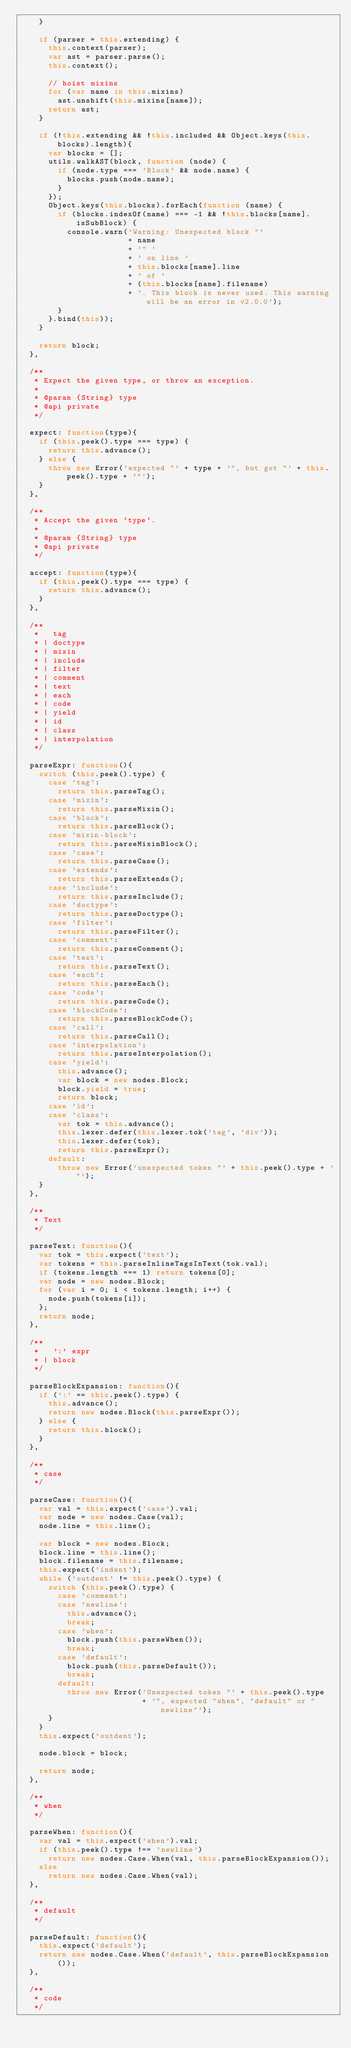Convert code to text. <code><loc_0><loc_0><loc_500><loc_500><_JavaScript_>    }

    if (parser = this.extending) {
      this.context(parser);
      var ast = parser.parse();
      this.context();

      // hoist mixins
      for (var name in this.mixins)
        ast.unshift(this.mixins[name]);
      return ast;
    }

    if (!this.extending && !this.included && Object.keys(this.blocks).length){
      var blocks = [];
      utils.walkAST(block, function (node) {
        if (node.type === 'Block' && node.name) {
          blocks.push(node.name);
        }
      });
      Object.keys(this.blocks).forEach(function (name) {
        if (blocks.indexOf(name) === -1 && !this.blocks[name].isSubBlock) {
          console.warn('Warning: Unexpected block "'
                       + name
                       + '" '
                       + ' on line '
                       + this.blocks[name].line
                       + ' of '
                       + (this.blocks[name].filename)
                       + '. This block is never used. This warning will be an error in v2.0.0');
        }
      }.bind(this));
    }

    return block;
  },

  /**
   * Expect the given type, or throw an exception.
   *
   * @param {String} type
   * @api private
   */

  expect: function(type){
    if (this.peek().type === type) {
      return this.advance();
    } else {
      throw new Error('expected "' + type + '", but got "' + this.peek().type + '"');
    }
  },

  /**
   * Accept the given `type`.
   *
   * @param {String} type
   * @api private
   */

  accept: function(type){
    if (this.peek().type === type) {
      return this.advance();
    }
  },

  /**
   *   tag
   * | doctype
   * | mixin
   * | include
   * | filter
   * | comment
   * | text
   * | each
   * | code
   * | yield
   * | id
   * | class
   * | interpolation
   */

  parseExpr: function(){
    switch (this.peek().type) {
      case 'tag':
        return this.parseTag();
      case 'mixin':
        return this.parseMixin();
      case 'block':
        return this.parseBlock();
      case 'mixin-block':
        return this.parseMixinBlock();
      case 'case':
        return this.parseCase();
      case 'extends':
        return this.parseExtends();
      case 'include':
        return this.parseInclude();
      case 'doctype':
        return this.parseDoctype();
      case 'filter':
        return this.parseFilter();
      case 'comment':
        return this.parseComment();
      case 'text':
        return this.parseText();
      case 'each':
        return this.parseEach();
      case 'code':
        return this.parseCode();
      case 'blockCode':
        return this.parseBlockCode();
      case 'call':
        return this.parseCall();
      case 'interpolation':
        return this.parseInterpolation();
      case 'yield':
        this.advance();
        var block = new nodes.Block;
        block.yield = true;
        return block;
      case 'id':
      case 'class':
        var tok = this.advance();
        this.lexer.defer(this.lexer.tok('tag', 'div'));
        this.lexer.defer(tok);
        return this.parseExpr();
      default:
        throw new Error('unexpected token "' + this.peek().type + '"');
    }
  },

  /**
   * Text
   */

  parseText: function(){
    var tok = this.expect('text');
    var tokens = this.parseInlineTagsInText(tok.val);
    if (tokens.length === 1) return tokens[0];
    var node = new nodes.Block;
    for (var i = 0; i < tokens.length; i++) {
      node.push(tokens[i]);
    };
    return node;
  },

  /**
   *   ':' expr
   * | block
   */

  parseBlockExpansion: function(){
    if (':' == this.peek().type) {
      this.advance();
      return new nodes.Block(this.parseExpr());
    } else {
      return this.block();
    }
  },

  /**
   * case
   */

  parseCase: function(){
    var val = this.expect('case').val;
    var node = new nodes.Case(val);
    node.line = this.line();

    var block = new nodes.Block;
    block.line = this.line();
    block.filename = this.filename;
    this.expect('indent');
    while ('outdent' != this.peek().type) {
      switch (this.peek().type) {
        case 'comment':
        case 'newline':
          this.advance();
          break;
        case 'when':
          block.push(this.parseWhen());
          break;
        case 'default':
          block.push(this.parseDefault());
          break;
        default:
          throw new Error('Unexpected token "' + this.peek().type
                          + '", expected "when", "default" or "newline"');
      }
    }
    this.expect('outdent');

    node.block = block;

    return node;
  },

  /**
   * when
   */

  parseWhen: function(){
    var val = this.expect('when').val;
    if (this.peek().type !== 'newline')
      return new nodes.Case.When(val, this.parseBlockExpansion());
    else
      return new nodes.Case.When(val);
  },

  /**
   * default
   */

  parseDefault: function(){
    this.expect('default');
    return new nodes.Case.When('default', this.parseBlockExpansion());
  },

  /**
   * code
   */
</code> 